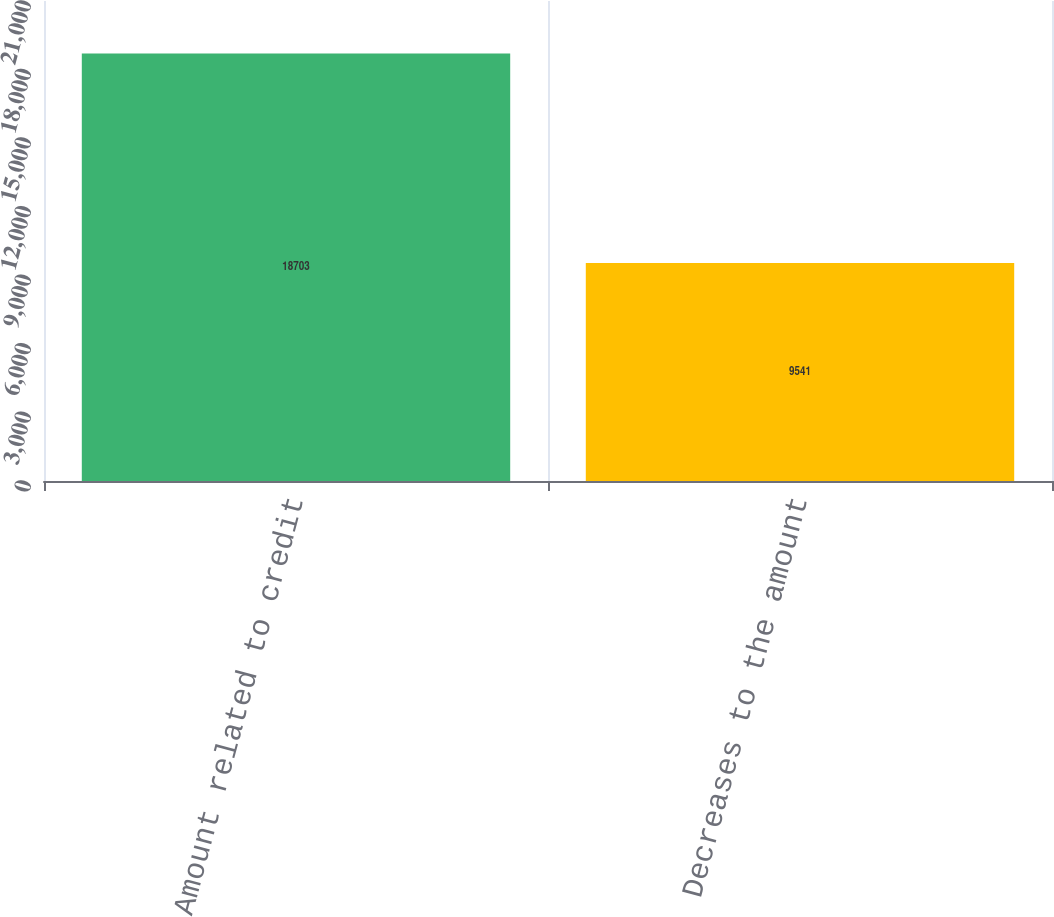<chart> <loc_0><loc_0><loc_500><loc_500><bar_chart><fcel>Amount related to credit<fcel>Decreases to the amount<nl><fcel>18703<fcel>9541<nl></chart> 